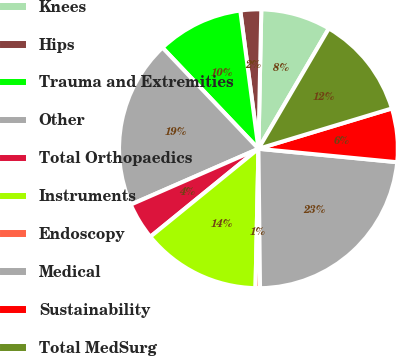<chart> <loc_0><loc_0><loc_500><loc_500><pie_chart><fcel>Knees<fcel>Hips<fcel>Trauma and Extremities<fcel>Other<fcel>Total Orthopaedics<fcel>Instruments<fcel>Endoscopy<fcel>Medical<fcel>Sustainability<fcel>Total MedSurg<nl><fcel>8.1%<fcel>2.41%<fcel>10.0%<fcel>19.48%<fcel>4.31%<fcel>13.79%<fcel>0.52%<fcel>23.28%<fcel>6.21%<fcel>11.9%<nl></chart> 